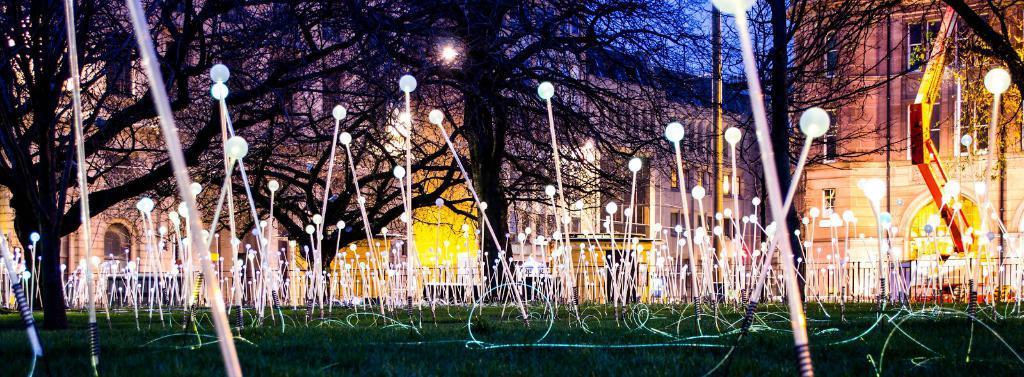Describe this image in one or two sentences. In this image, we can see grass on the ground, there are some lights, there are some trees, we can see some buildings. 